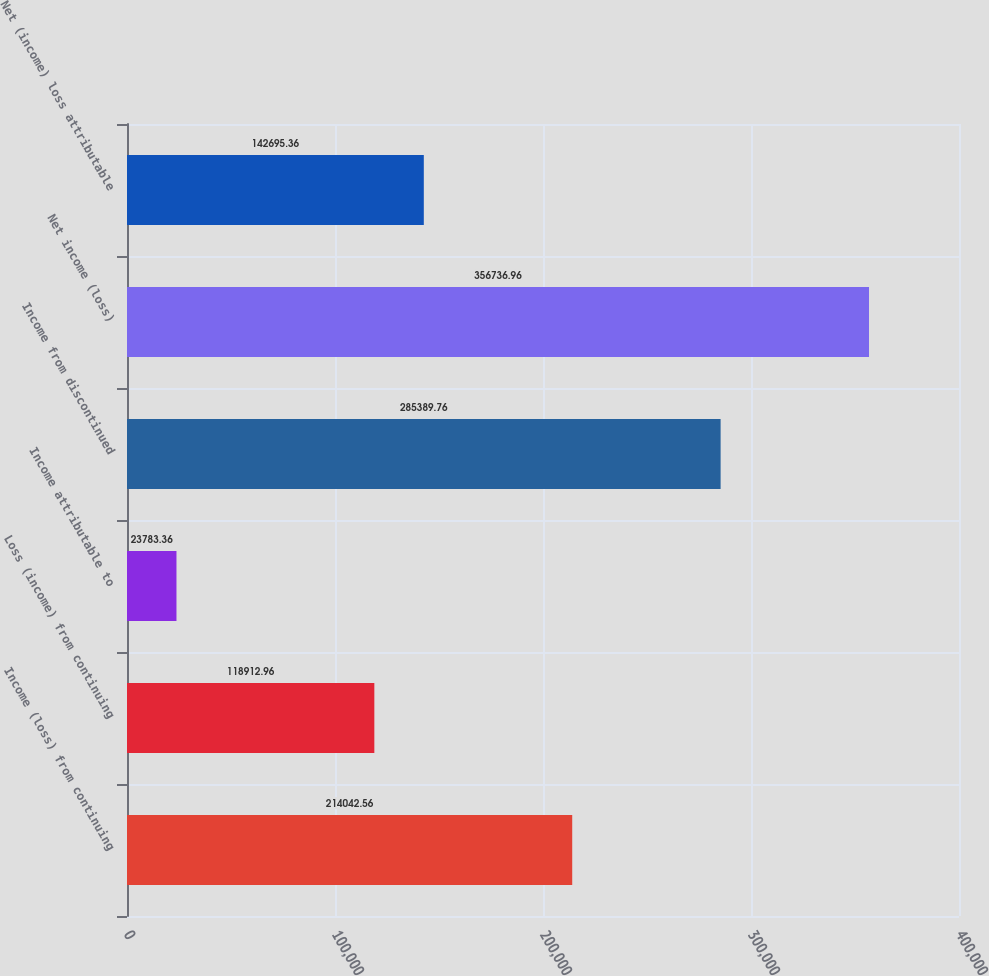<chart> <loc_0><loc_0><loc_500><loc_500><bar_chart><fcel>Income (loss) from continuing<fcel>Loss (income) from continuing<fcel>Income attributable to<fcel>Income from discontinued<fcel>Net income (loss)<fcel>Net (income) loss attributable<nl><fcel>214043<fcel>118913<fcel>23783.4<fcel>285390<fcel>356737<fcel>142695<nl></chart> 